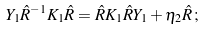<formula> <loc_0><loc_0><loc_500><loc_500>Y _ { 1 } \hat { R } ^ { - 1 } K _ { 1 } \hat { R } = \hat { R } K _ { 1 } \hat { R } Y _ { 1 } + \eta _ { 2 } \hat { R } \, ;</formula> 